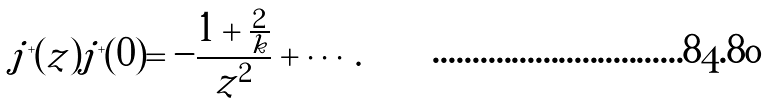Convert formula to latex. <formula><loc_0><loc_0><loc_500><loc_500>j ^ { + } ( z ) j ^ { + } ( 0 ) = - \frac { 1 + \frac { 2 } { k } } { z ^ { 2 } } + \cdots .</formula> 